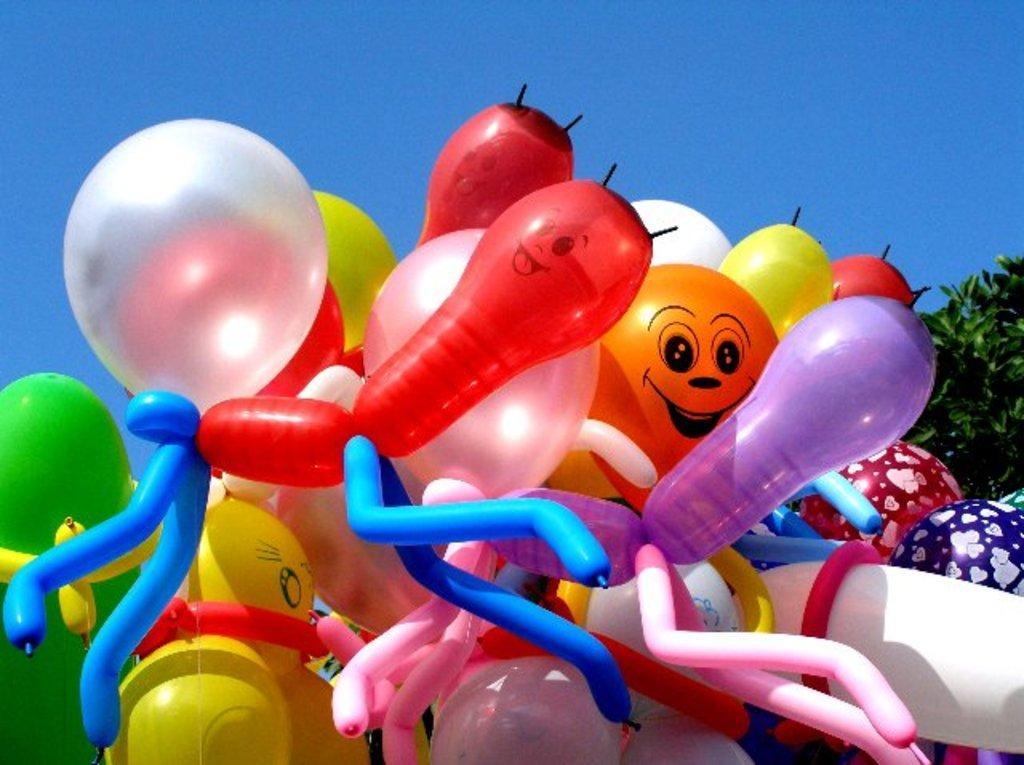Please provide a concise description of this image. In this image we can see some balloons, trees and the sky. 